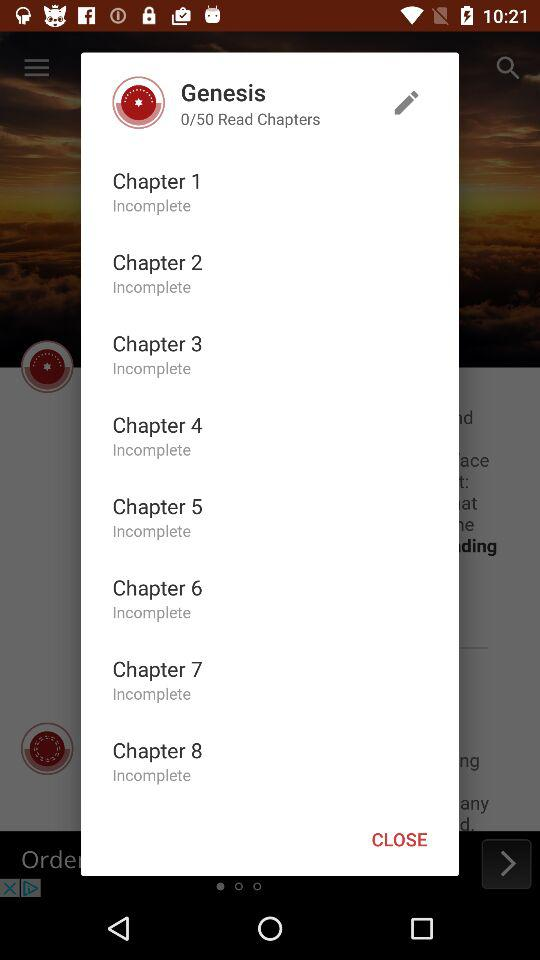How many chapters are incomplete?
Answer the question using a single word or phrase. 8 